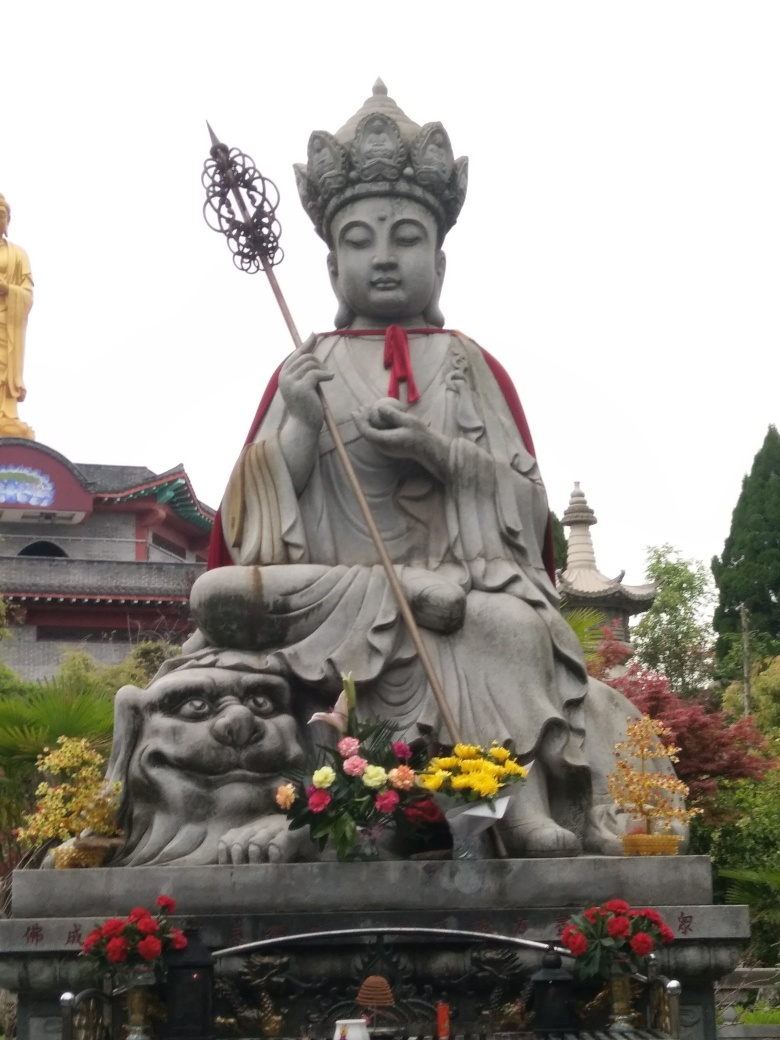What elements of the image suggest the location or setting where the statue is situated? The statue is set against a backdrop of what seems to be a landscaped area with flora that includes blooming flowers and cultivated shrubs. Additionally, the architectural elements visible in the background, specifically the roof design, hint at an East Asian setting, likely a temple or a sacred garden. Such locations are typically chosen for their serenity and beauty, contributing to the peaceful and contemplative atmosphere that complements the spiritual significance of the statue. 